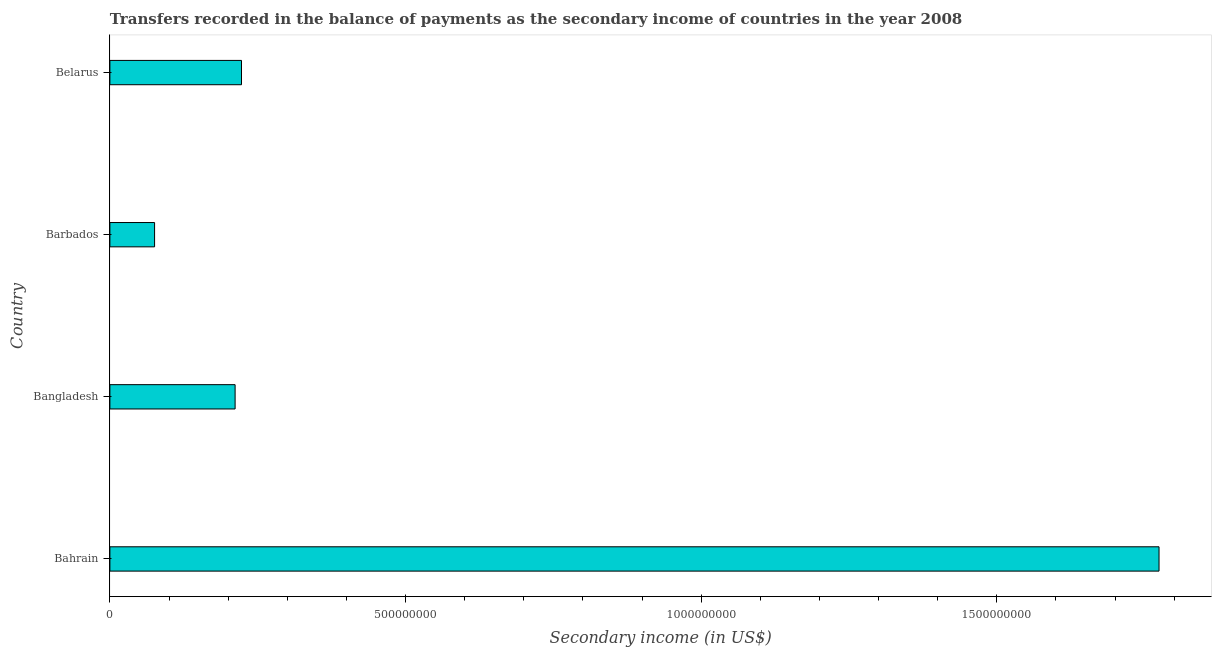Does the graph contain grids?
Make the answer very short. No. What is the title of the graph?
Your answer should be compact. Transfers recorded in the balance of payments as the secondary income of countries in the year 2008. What is the label or title of the X-axis?
Provide a succinct answer. Secondary income (in US$). What is the label or title of the Y-axis?
Your answer should be compact. Country. What is the amount of secondary income in Bangladesh?
Provide a short and direct response. 2.12e+08. Across all countries, what is the maximum amount of secondary income?
Give a very brief answer. 1.77e+09. Across all countries, what is the minimum amount of secondary income?
Your response must be concise. 7.56e+07. In which country was the amount of secondary income maximum?
Provide a short and direct response. Bahrain. In which country was the amount of secondary income minimum?
Offer a terse response. Barbados. What is the sum of the amount of secondary income?
Keep it short and to the point. 2.28e+09. What is the difference between the amount of secondary income in Bahrain and Belarus?
Offer a terse response. 1.55e+09. What is the average amount of secondary income per country?
Keep it short and to the point. 5.71e+08. What is the median amount of secondary income?
Your answer should be very brief. 2.17e+08. In how many countries, is the amount of secondary income greater than 700000000 US$?
Ensure brevity in your answer.  1. What is the ratio of the amount of secondary income in Bangladesh to that in Barbados?
Provide a succinct answer. 2.8. Is the difference between the amount of secondary income in Bangladesh and Belarus greater than the difference between any two countries?
Make the answer very short. No. What is the difference between the highest and the second highest amount of secondary income?
Provide a succinct answer. 1.55e+09. Is the sum of the amount of secondary income in Bahrain and Belarus greater than the maximum amount of secondary income across all countries?
Give a very brief answer. Yes. What is the difference between the highest and the lowest amount of secondary income?
Provide a succinct answer. 1.70e+09. In how many countries, is the amount of secondary income greater than the average amount of secondary income taken over all countries?
Offer a very short reply. 1. How many bars are there?
Ensure brevity in your answer.  4. Are all the bars in the graph horizontal?
Make the answer very short. Yes. Are the values on the major ticks of X-axis written in scientific E-notation?
Your answer should be compact. No. What is the Secondary income (in US$) in Bahrain?
Ensure brevity in your answer.  1.77e+09. What is the Secondary income (in US$) of Bangladesh?
Ensure brevity in your answer.  2.12e+08. What is the Secondary income (in US$) in Barbados?
Keep it short and to the point. 7.56e+07. What is the Secondary income (in US$) in Belarus?
Your answer should be very brief. 2.23e+08. What is the difference between the Secondary income (in US$) in Bahrain and Bangladesh?
Ensure brevity in your answer.  1.56e+09. What is the difference between the Secondary income (in US$) in Bahrain and Barbados?
Keep it short and to the point. 1.70e+09. What is the difference between the Secondary income (in US$) in Bahrain and Belarus?
Keep it short and to the point. 1.55e+09. What is the difference between the Secondary income (in US$) in Bangladesh and Barbados?
Ensure brevity in your answer.  1.36e+08. What is the difference between the Secondary income (in US$) in Bangladesh and Belarus?
Your answer should be very brief. -1.08e+07. What is the difference between the Secondary income (in US$) in Barbados and Belarus?
Your response must be concise. -1.47e+08. What is the ratio of the Secondary income (in US$) in Bahrain to that in Bangladesh?
Offer a very short reply. 8.38. What is the ratio of the Secondary income (in US$) in Bahrain to that in Barbados?
Offer a very short reply. 23.47. What is the ratio of the Secondary income (in US$) in Bahrain to that in Belarus?
Your response must be concise. 7.97. What is the ratio of the Secondary income (in US$) in Bangladesh to that in Barbados?
Provide a succinct answer. 2.8. What is the ratio of the Secondary income (in US$) in Bangladesh to that in Belarus?
Offer a very short reply. 0.95. What is the ratio of the Secondary income (in US$) in Barbados to that in Belarus?
Offer a terse response. 0.34. 